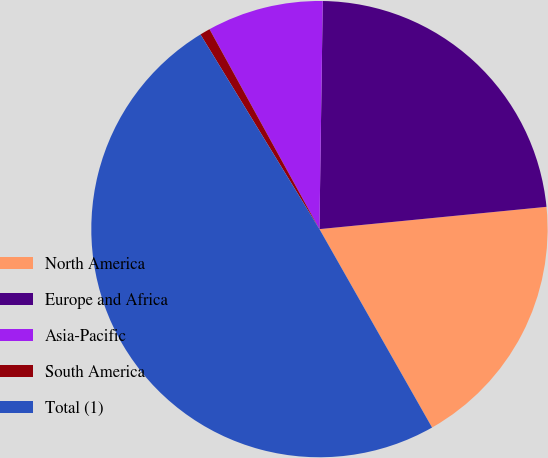Convert chart to OTSL. <chart><loc_0><loc_0><loc_500><loc_500><pie_chart><fcel>North America<fcel>Europe and Africa<fcel>Asia-Pacific<fcel>South America<fcel>Total (1)<nl><fcel>18.34%<fcel>23.21%<fcel>8.23%<fcel>0.73%<fcel>49.48%<nl></chart> 